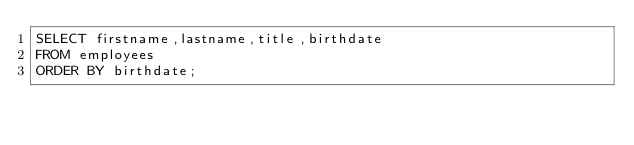<code> <loc_0><loc_0><loc_500><loc_500><_SQL_>SELECT firstname,lastname,title,birthdate
FROM employees
ORDER BY birthdate;</code> 